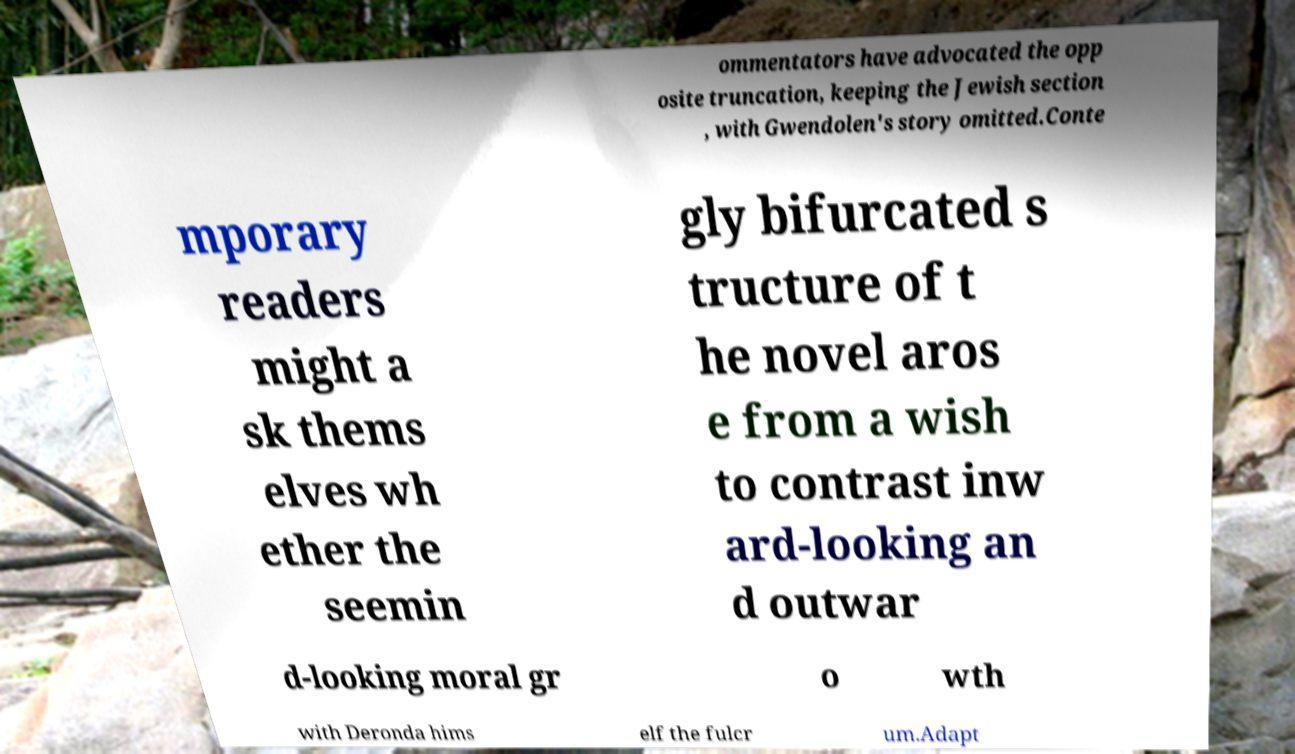Could you extract and type out the text from this image? ommentators have advocated the opp osite truncation, keeping the Jewish section , with Gwendolen's story omitted.Conte mporary readers might a sk thems elves wh ether the seemin gly bifurcated s tructure of t he novel aros e from a wish to contrast inw ard-looking an d outwar d-looking moral gr o wth with Deronda hims elf the fulcr um.Adapt 